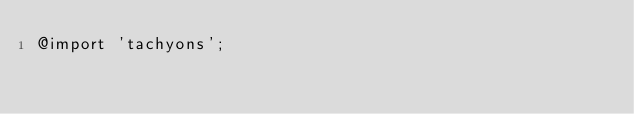<code> <loc_0><loc_0><loc_500><loc_500><_CSS_>@import 'tachyons';

</code> 